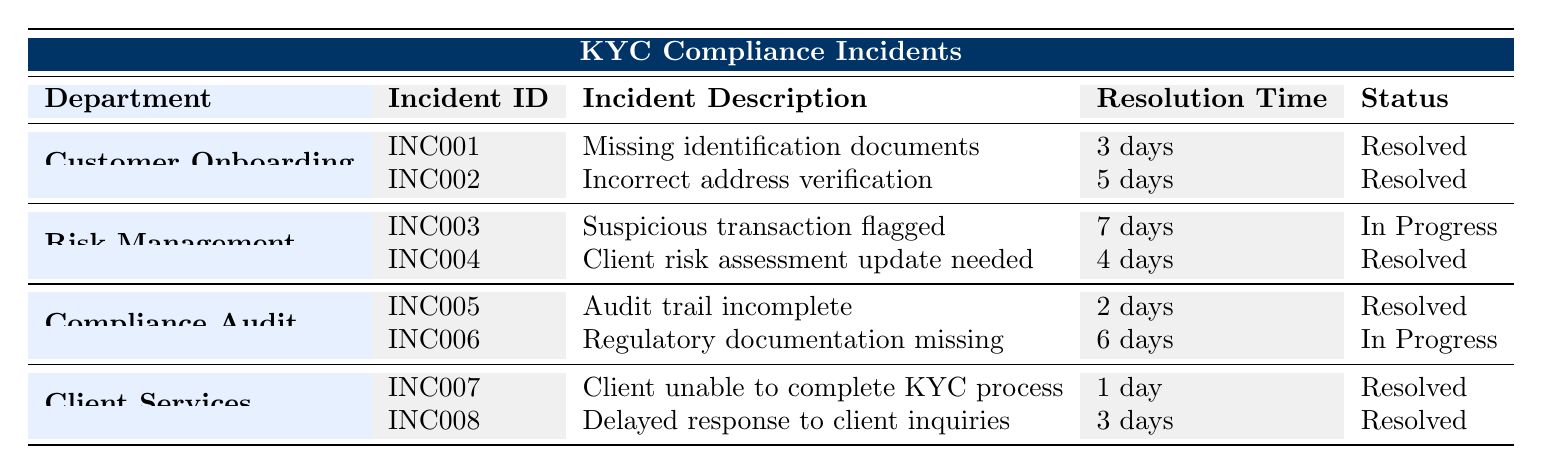What is the resolution time for the incident labeled INC007? In the table, the incident ID INC007 corresponds to the incident "Client unable to complete KYC process" which has a resolution time of "1 day."
Answer: 1 day How many incidents are currently in progress? By reviewing the table, I find two incidents with the status "In Progress": INC003 (Suspicious transaction flagged) and INC006 (Regulatory documentation missing). Therefore, the total is 2 incidents.
Answer: 2 Which department recorded the highest resolution time for an incident? Reviewing the resolution times for each department's incidents, the department of Risk Management has an incident (INC003) with a resolution time of "7 days," which is the highest compared to any others.
Answer: Risk Management Is there an unresolved incident related to the Compliance Audit department? Yes, upon inspection, the incident labeled INC006 ("Regulatory documentation missing") in the Compliance Audit department has the status "In Progress," indicating it is not resolved.
Answer: Yes What is the average resolution time for incidents in the Customer Onboarding department? The two incidents in the Customer Onboarding department have resolution times of 3 days and 5 days. Their average is calculated by summing these (3 + 5 = 8) and dividing by the number of incidents (8 / 2 = 4).
Answer: 4 days Which department has the least amount of resolution time? Examining the resolution times for all incidents, the department of Client Services has an incident (INC007) that resolved in just "1 day," making it the department with the least amount of resolution time overall.
Answer: Client Services What percentage of incidents in the Client Services department are resolved? The Client Services department has two incidents, both of which are marked as "Resolved." To find the percentage, I calculate (2 resolved incidents / 2 total incidents) * 100 = 100%.
Answer: 100% Which incident across all departments took the longest to resolve? Looking at all the resolution times, the incident INC003 from the Risk Management department took "7 days" to resolve, which is the longest duration among all incidents.
Answer: INC003 How many incidents in total are recorded for the Risk Management department? The Risk Management department has two documented incidents: INC003 and INC004. Therefore, the total number of incidents for this department is 2.
Answer: 2 